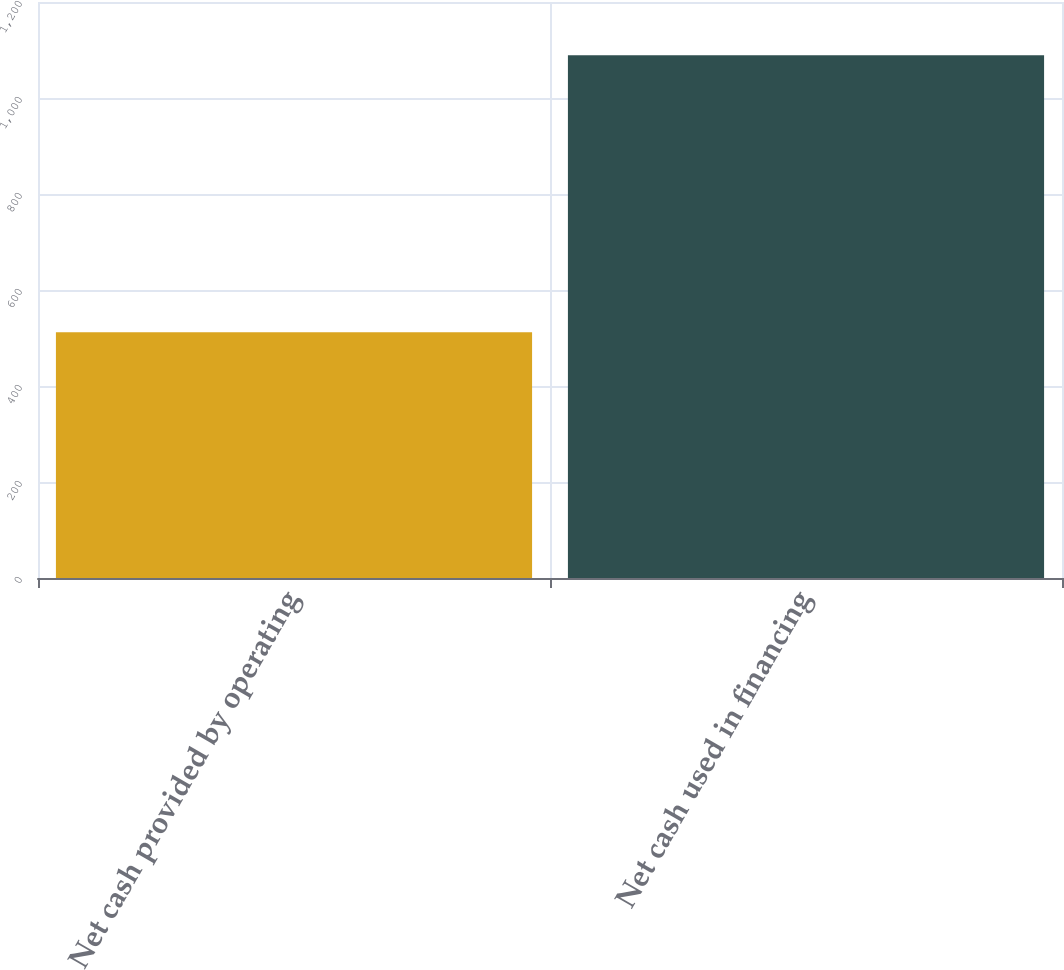Convert chart to OTSL. <chart><loc_0><loc_0><loc_500><loc_500><bar_chart><fcel>Net cash provided by operating<fcel>Net cash used in financing<nl><fcel>512<fcel>1089<nl></chart> 